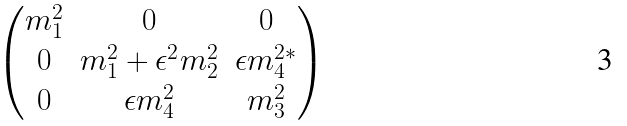<formula> <loc_0><loc_0><loc_500><loc_500>\begin{pmatrix} m _ { 1 } ^ { 2 } & 0 & 0 \\ 0 & m _ { 1 } ^ { 2 } + \epsilon ^ { 2 } m _ { 2 } ^ { 2 } & \epsilon m _ { 4 } ^ { 2 * } \\ 0 & \epsilon m _ { 4 } ^ { 2 } & m _ { 3 } ^ { 2 } \end{pmatrix}</formula> 